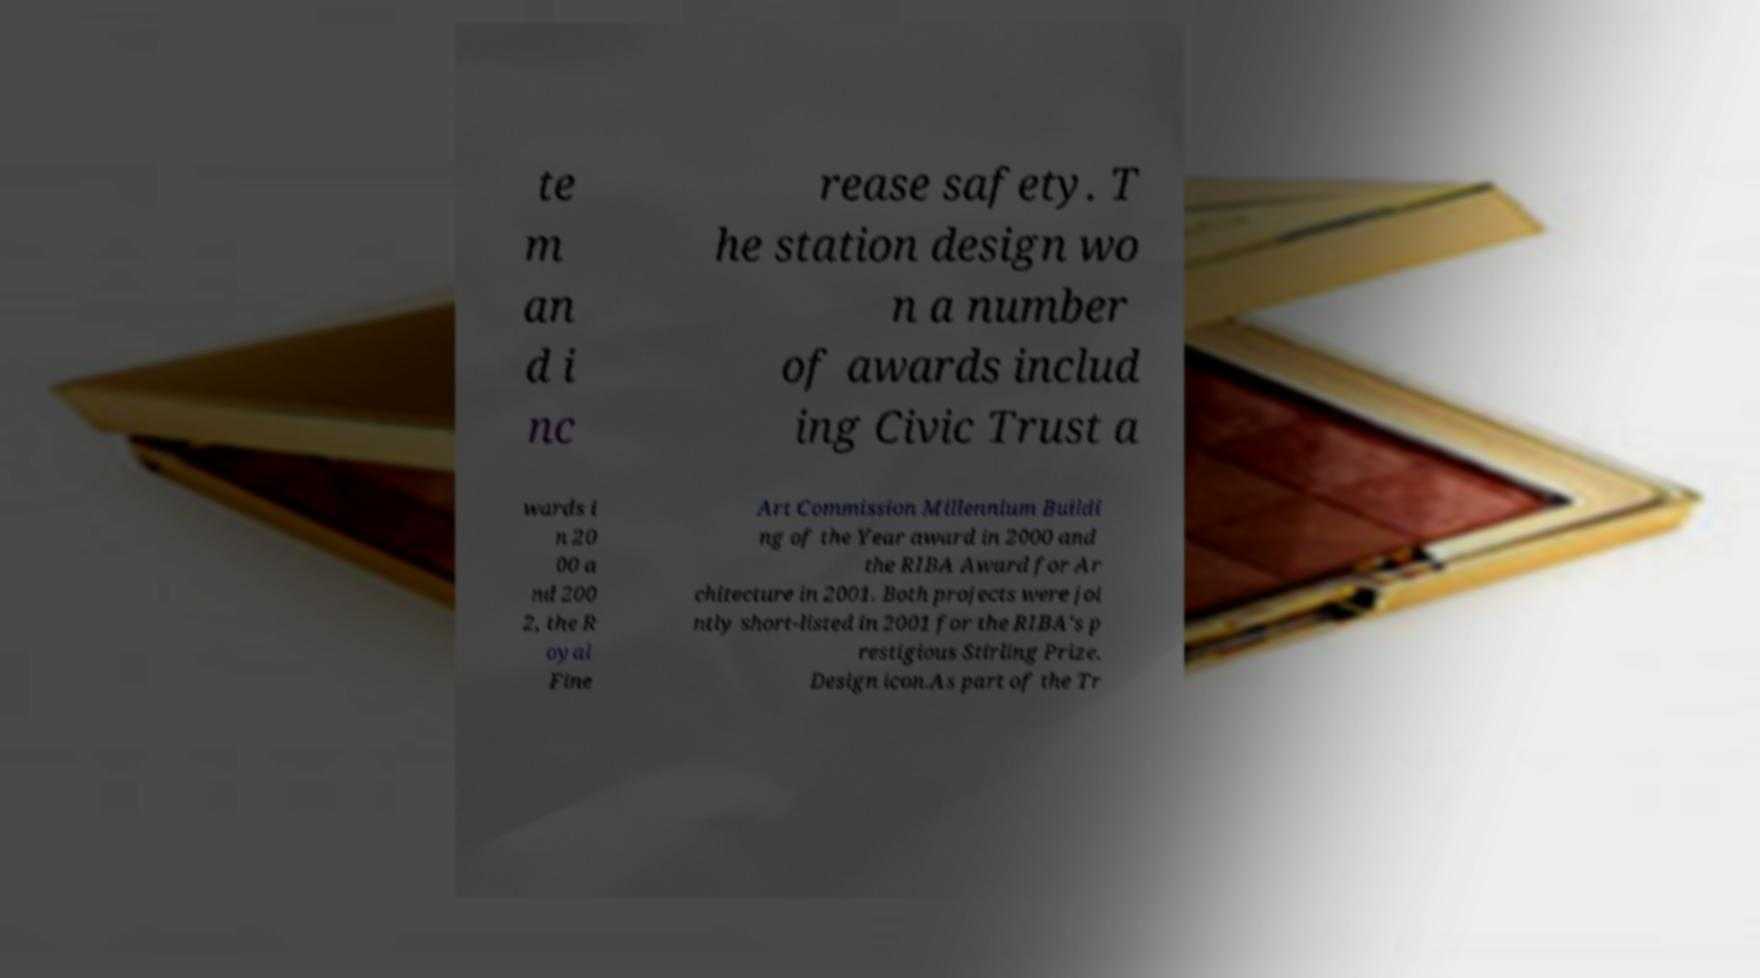What messages or text are displayed in this image? I need them in a readable, typed format. te m an d i nc rease safety. T he station design wo n a number of awards includ ing Civic Trust a wards i n 20 00 a nd 200 2, the R oyal Fine Art Commission Millennium Buildi ng of the Year award in 2000 and the RIBA Award for Ar chitecture in 2001. Both projects were joi ntly short-listed in 2001 for the RIBA's p restigious Stirling Prize. Design icon.As part of the Tr 